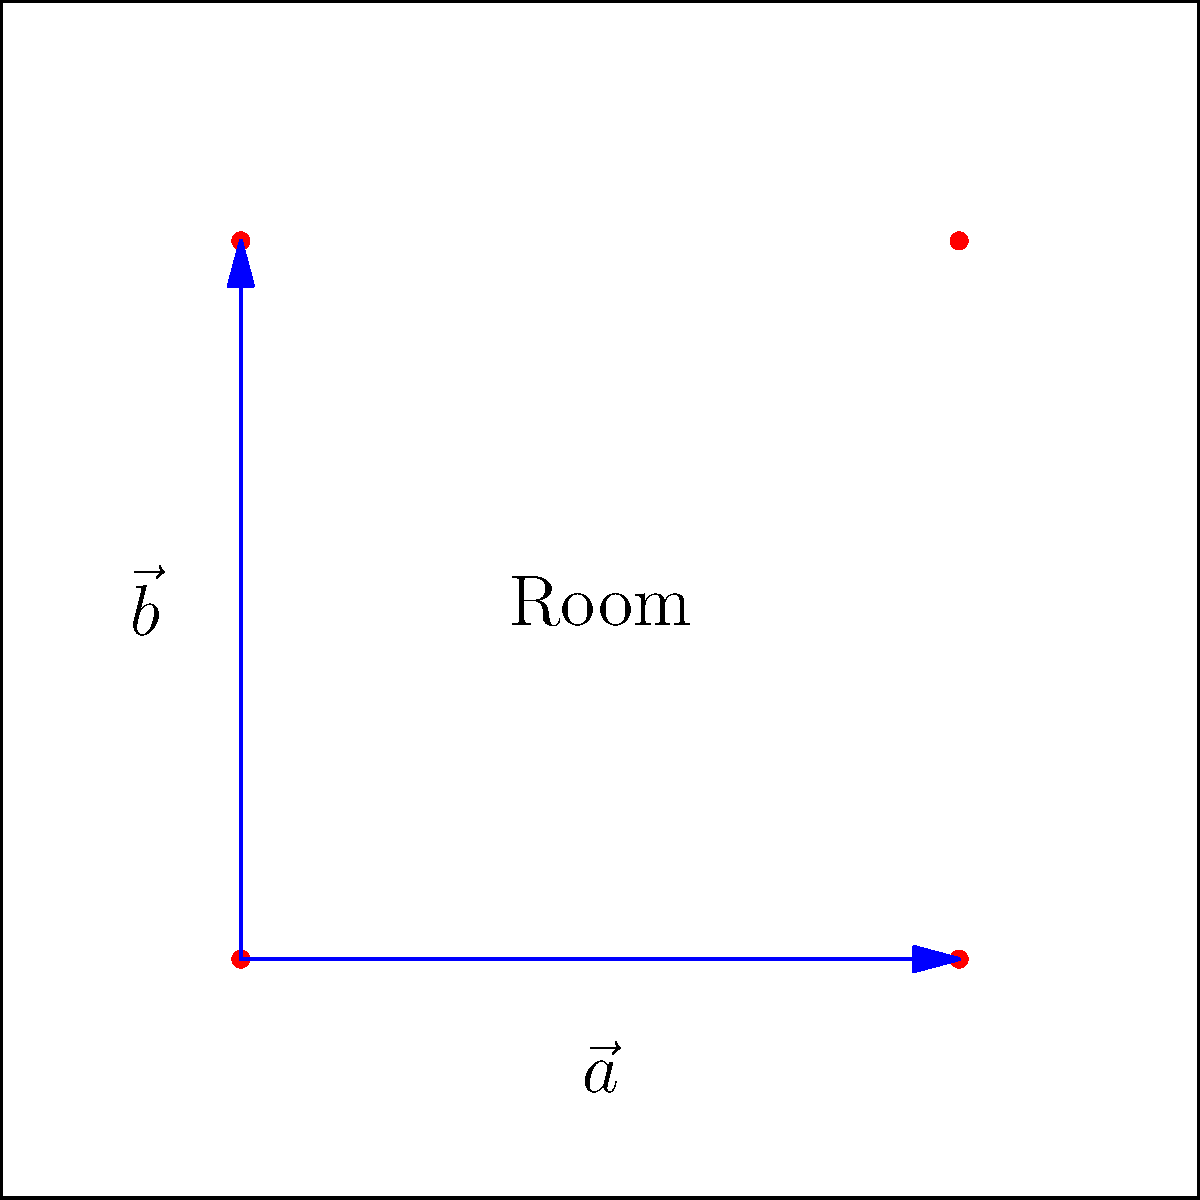In a rectangular room measuring 10m x 10m, air-purifying plants are to be placed at the corners of a rectangle within the room. If the placement vectors are $\vec{a} = 6\hat{i}$ and $\vec{b} = 6\hat{j}$, calculate the area covered by one set of plants and determine how many such sets can fit in the room to maximize air purification without overcrowding. To solve this problem, we'll follow these steps:

1. Calculate the area covered by one set of plants:
   - The area is given by the magnitude of the cross product of vectors $\vec{a}$ and $\vec{b}$
   - Area = $|\vec{a} \times \vec{b}| = |\vec{a}||\vec{b}|\sin\theta$
   - Since $\vec{a}$ and $\vec{b}$ are perpendicular, $\sin\theta = 1$
   - Area = $6 \times 6 = 36$ m²

2. Calculate the total room area:
   - Room area = $10 \text{ m} \times 10 \text{ m} = 100$ m²

3. Determine the number of plant sets that can fit:
   - Number of sets = Total room area ÷ Area per set
   - Number of sets = $100 \text{ m²} \div 36 \text{ m²} \approx 2.78$

4. Round down to the nearest whole number to avoid overcrowding:
   - Maximum number of sets = 2

5. Calculate the optimal planting density:
   - Total plants = 4 plants per set × 2 sets = 8 plants
   - Optimal density = 8 plants ÷ 100 m² = 0.08 plants/m²
Answer: 2 sets; 0.08 plants/m² 